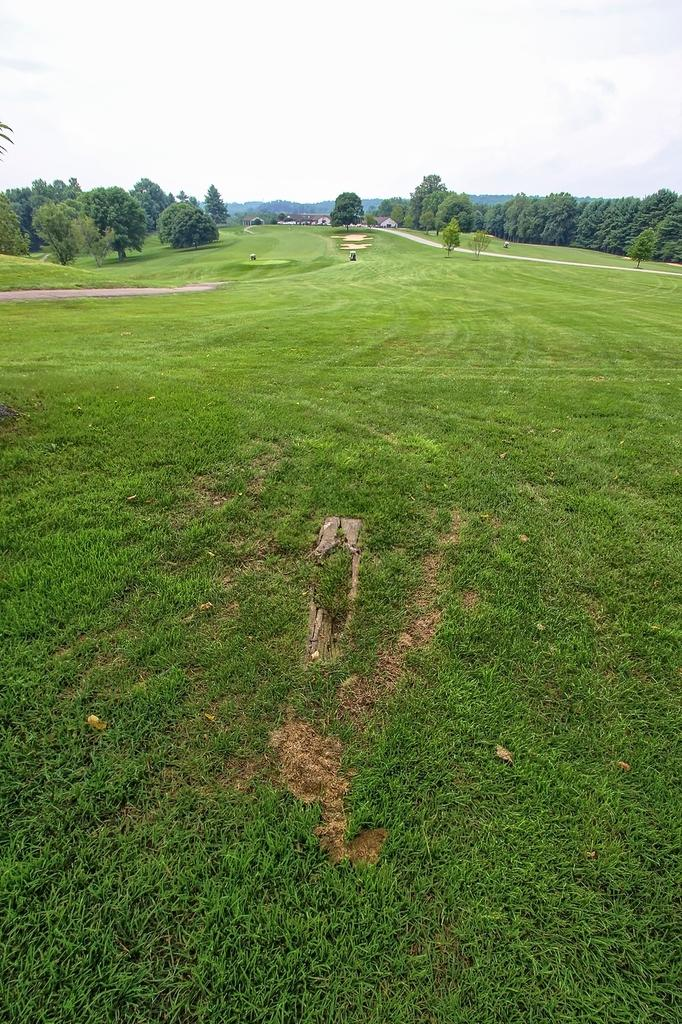What is the main feature of the image? There is a green field in the image. What can be seen on either side of the green field? There are trees on either side of the field. What structures are visible in the background of the image? There are houses in the background of the image. How would you describe the sky in the image? The sky is cloudy in the background of the image. What type of lead can be seen in the image? There is no lead present in the image. 